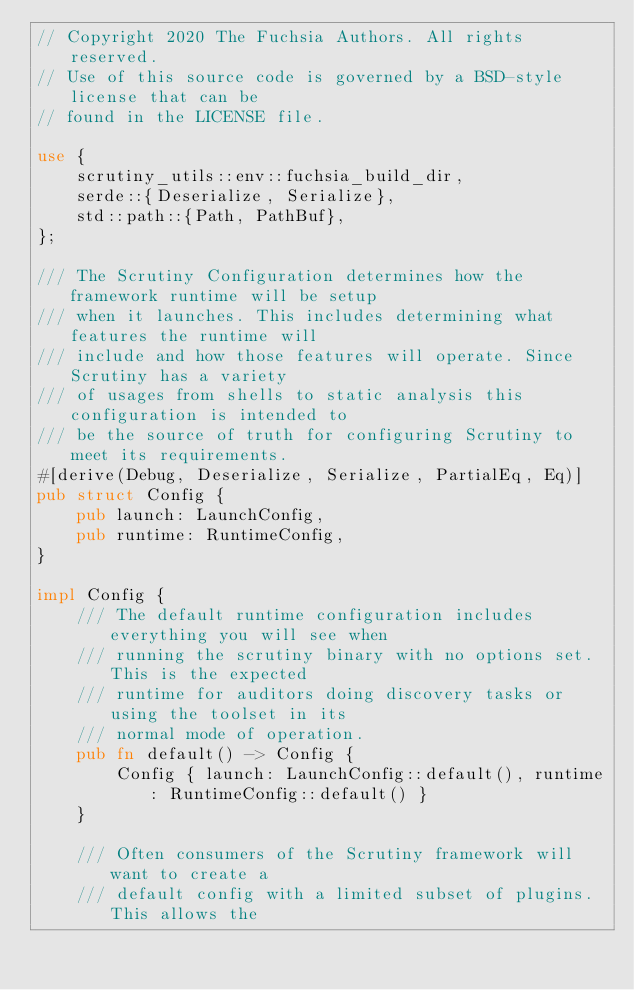Convert code to text. <code><loc_0><loc_0><loc_500><loc_500><_Rust_>// Copyright 2020 The Fuchsia Authors. All rights reserved.
// Use of this source code is governed by a BSD-style license that can be
// found in the LICENSE file.

use {
    scrutiny_utils::env::fuchsia_build_dir,
    serde::{Deserialize, Serialize},
    std::path::{Path, PathBuf},
};

/// The Scrutiny Configuration determines how the framework runtime will be setup
/// when it launches. This includes determining what features the runtime will
/// include and how those features will operate. Since Scrutiny has a variety
/// of usages from shells to static analysis this configuration is intended to
/// be the source of truth for configuring Scrutiny to meet its requirements.
#[derive(Debug, Deserialize, Serialize, PartialEq, Eq)]
pub struct Config {
    pub launch: LaunchConfig,
    pub runtime: RuntimeConfig,
}

impl Config {
    /// The default runtime configuration includes everything you will see when
    /// running the scrutiny binary with no options set. This is the expected
    /// runtime for auditors doing discovery tasks or using the toolset in its
    /// normal mode of operation.
    pub fn default() -> Config {
        Config { launch: LaunchConfig::default(), runtime: RuntimeConfig::default() }
    }

    /// Often consumers of the Scrutiny framework will want to create a
    /// default config with a limited subset of plugins. This allows the</code> 